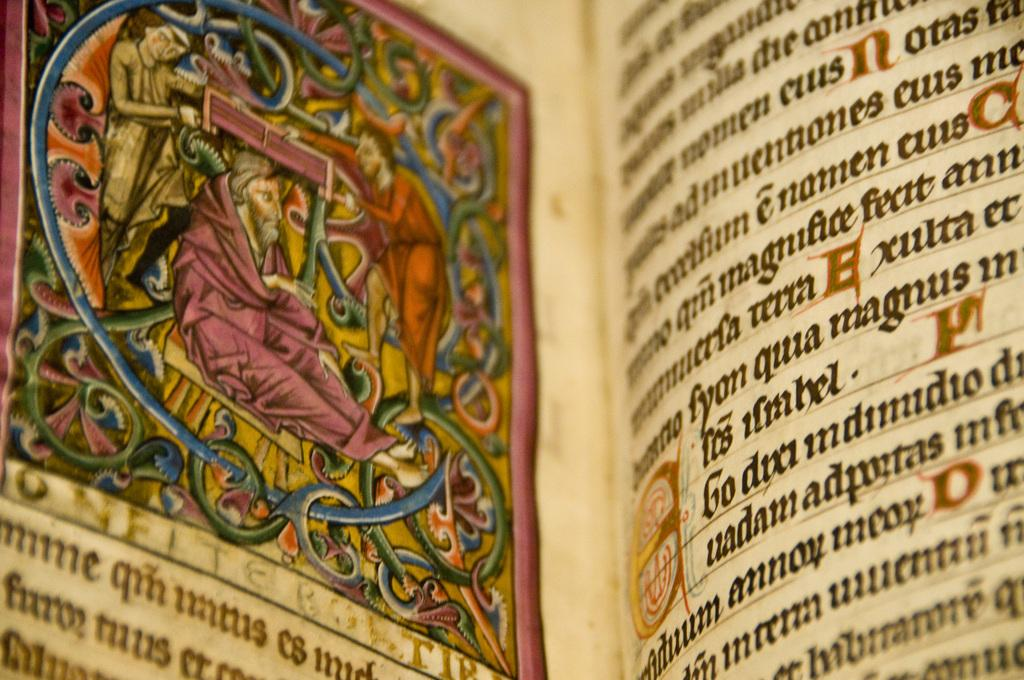<image>
Present a compact description of the photo's key features. A book is shown that is written in foreign language and has a colored image in it. 